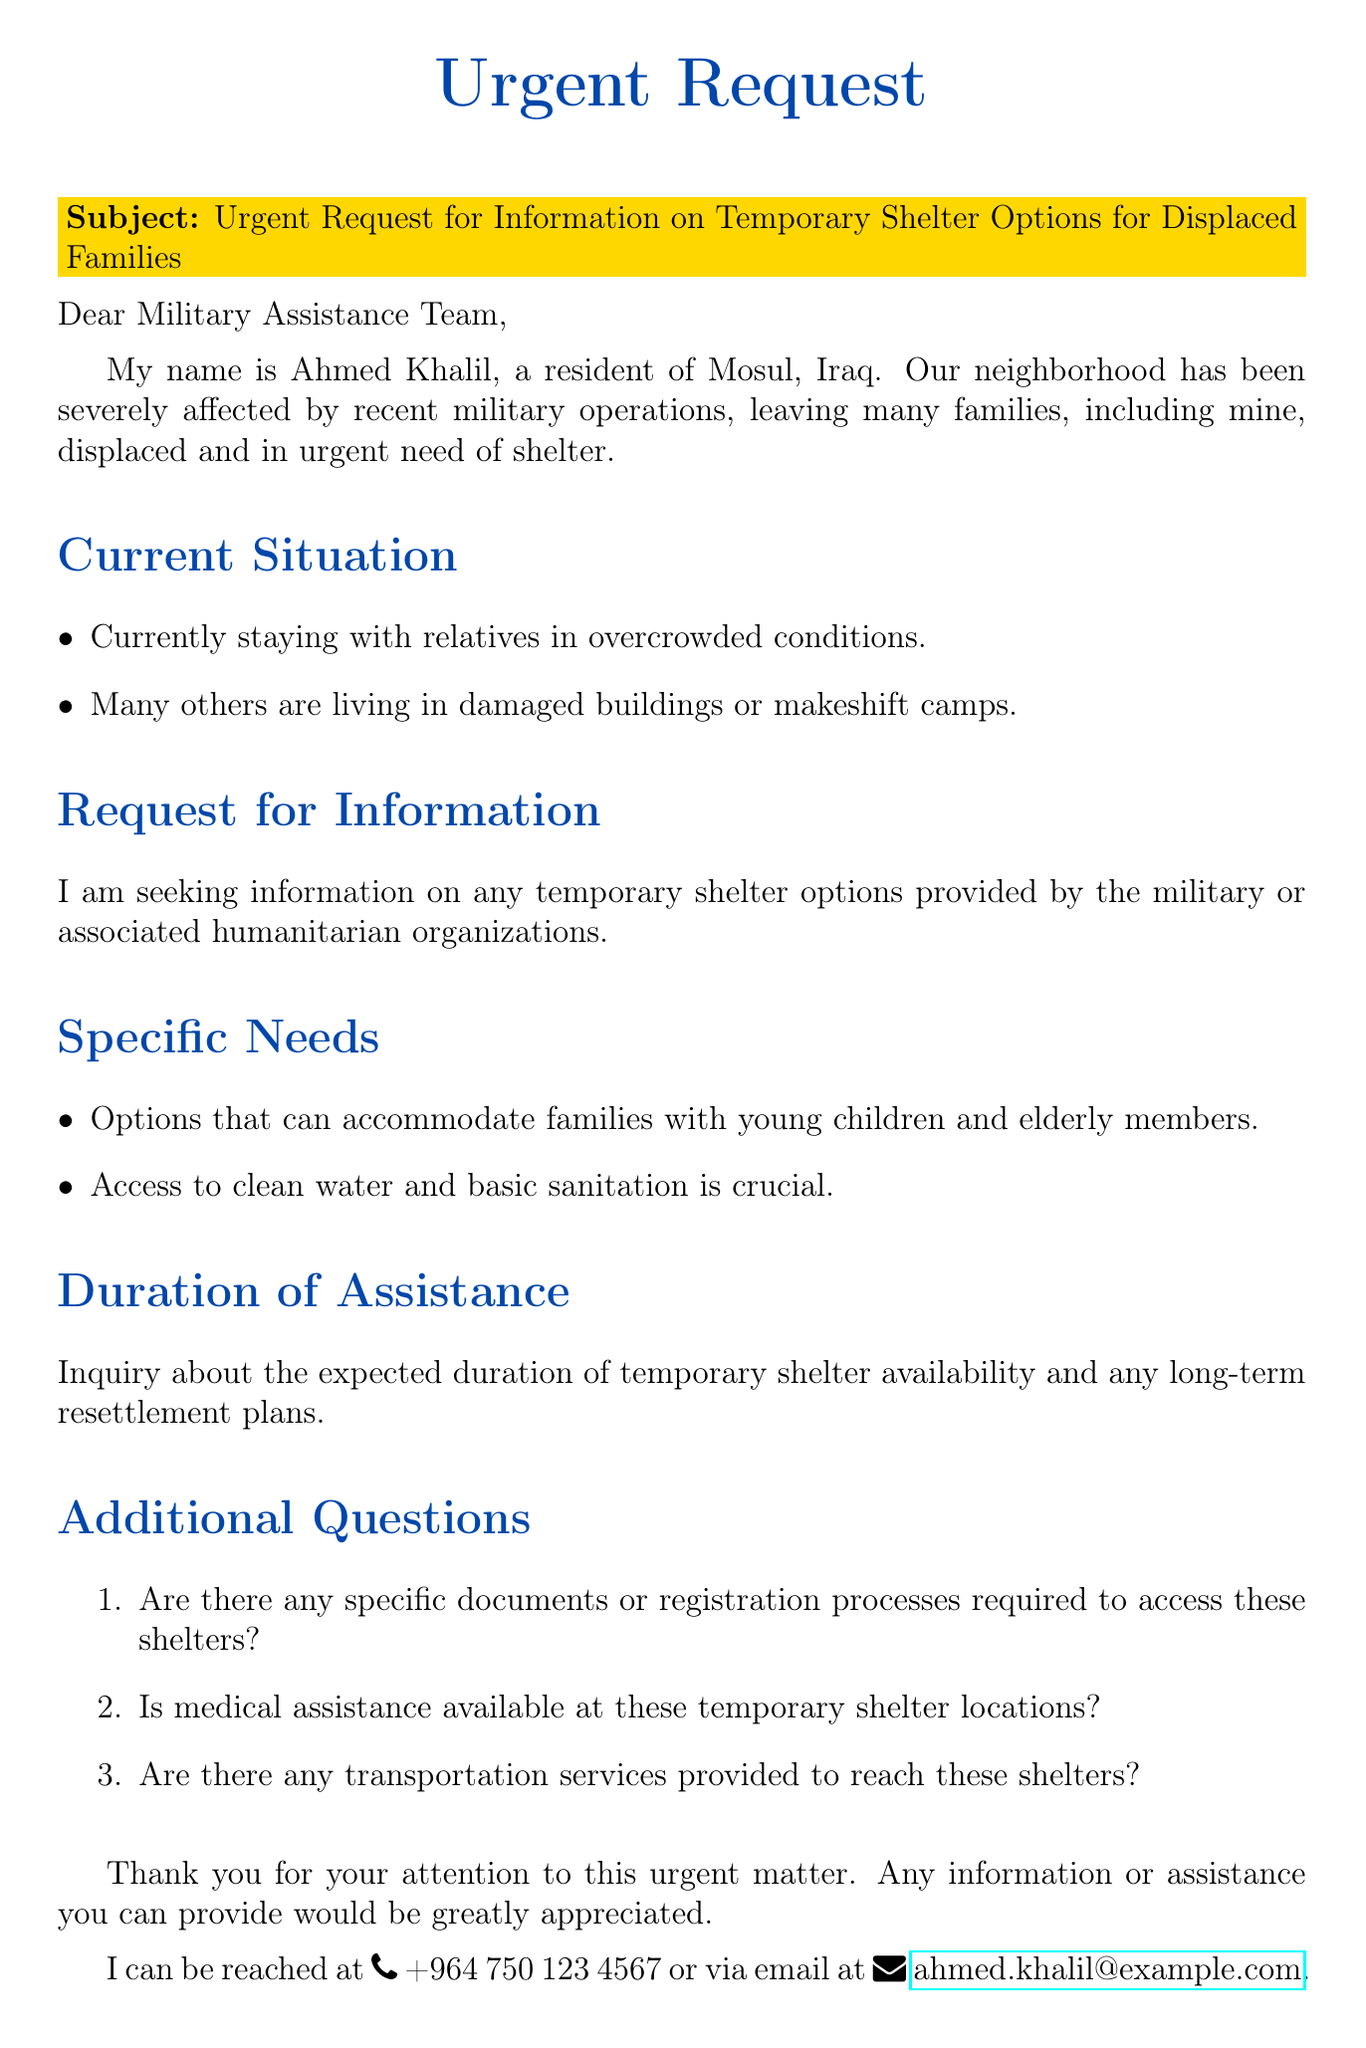What is the name of the sender? The name of the sender is provided at the end of the email.
Answer: Ahmed Khalil What is the location mentioned in the email? The email states that the sender resides in a specific city affected by the situation.
Answer: Mosul, Iraq What specific need is mentioned regarding family accommodations? The email highlights a particular aspect of family accommodations that is critical.
Answer: Young children and elderly members What is the contact phone number provided? The email includes a phone number for the sender to be contacted.
Answer: +964 750 123 4567 What type of assistance is inquired about at the temporary shelters? The email asks for specific amenities that are crucial for displaced families residing in shelters.
Answer: Medical assistance What does the sender express gratitude for? The sender's gratitude is directed towards the recipients of the email for their potential aid.
Answer: Attention to this urgent matter What are the living conditions of many displaced families described as? The email details the current state of living for many individuals and families affected.
Answer: Overcrowded conditions What does the sender seek from humanitarian organizations? The email explicitly mentions what the sender is looking for in terms of support.
Answer: Temporary shelter options How many specific questions are listed in the email? The email contains a specific number of additional inquiries for clarification.
Answer: Three 